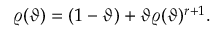<formula> <loc_0><loc_0><loc_500><loc_500>\varrho ( \vartheta ) = ( 1 - \vartheta ) + \vartheta \varrho ( \vartheta ) ^ { r + 1 } .</formula> 